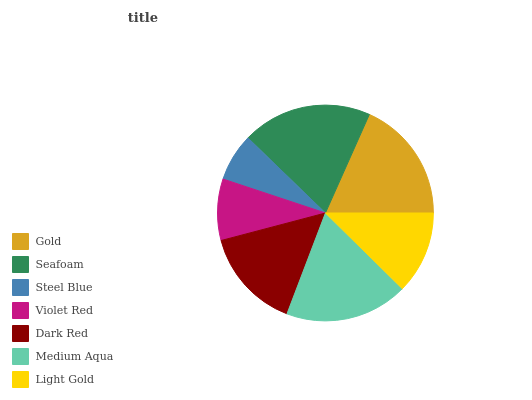Is Steel Blue the minimum?
Answer yes or no. Yes. Is Seafoam the maximum?
Answer yes or no. Yes. Is Seafoam the minimum?
Answer yes or no. No. Is Steel Blue the maximum?
Answer yes or no. No. Is Seafoam greater than Steel Blue?
Answer yes or no. Yes. Is Steel Blue less than Seafoam?
Answer yes or no. Yes. Is Steel Blue greater than Seafoam?
Answer yes or no. No. Is Seafoam less than Steel Blue?
Answer yes or no. No. Is Dark Red the high median?
Answer yes or no. Yes. Is Dark Red the low median?
Answer yes or no. Yes. Is Light Gold the high median?
Answer yes or no. No. Is Medium Aqua the low median?
Answer yes or no. No. 